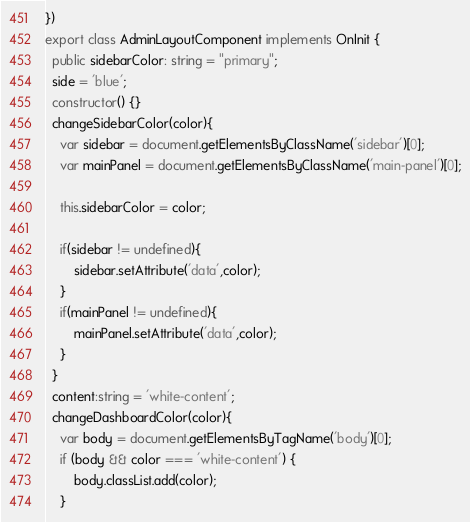Convert code to text. <code><loc_0><loc_0><loc_500><loc_500><_TypeScript_>})
export class AdminLayoutComponent implements OnInit {
  public sidebarColor: string = "primary";
  side = 'blue';
  constructor() {}
  changeSidebarColor(color){
    var sidebar = document.getElementsByClassName('sidebar')[0];
    var mainPanel = document.getElementsByClassName('main-panel')[0];

    this.sidebarColor = color;

    if(sidebar != undefined){
        sidebar.setAttribute('data',color);
    }
    if(mainPanel != undefined){
        mainPanel.setAttribute('data',color);
    }
  }
  content:string = 'white-content';
  changeDashboardColor(color){
    var body = document.getElementsByTagName('body')[0];
    if (body && color === 'white-content') {
        body.classList.add(color);
    }</code> 